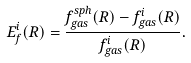Convert formula to latex. <formula><loc_0><loc_0><loc_500><loc_500>E _ { f } ^ { i } ( R ) = \frac { f ^ { s p h } _ { g a s } ( R ) - f ^ { i } _ { g a s } ( R ) } { f ^ { i } _ { g a s } ( R ) } .</formula> 